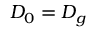<formula> <loc_0><loc_0><loc_500><loc_500>D _ { 0 } = D _ { g }</formula> 